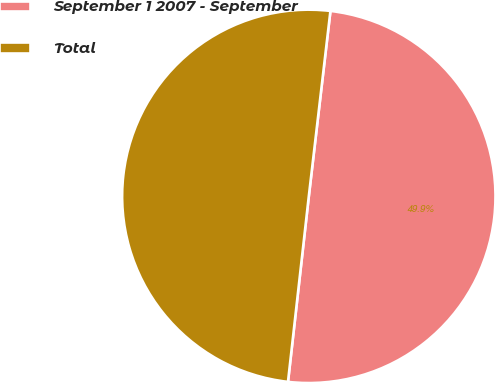Convert chart to OTSL. <chart><loc_0><loc_0><loc_500><loc_500><pie_chart><fcel>September 1 2007 - September<fcel>Total<nl><fcel>49.93%<fcel>50.07%<nl></chart> 